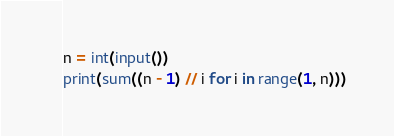<code> <loc_0><loc_0><loc_500><loc_500><_Python_>n = int(input())
print(sum((n - 1) // i for i in range(1, n)))</code> 